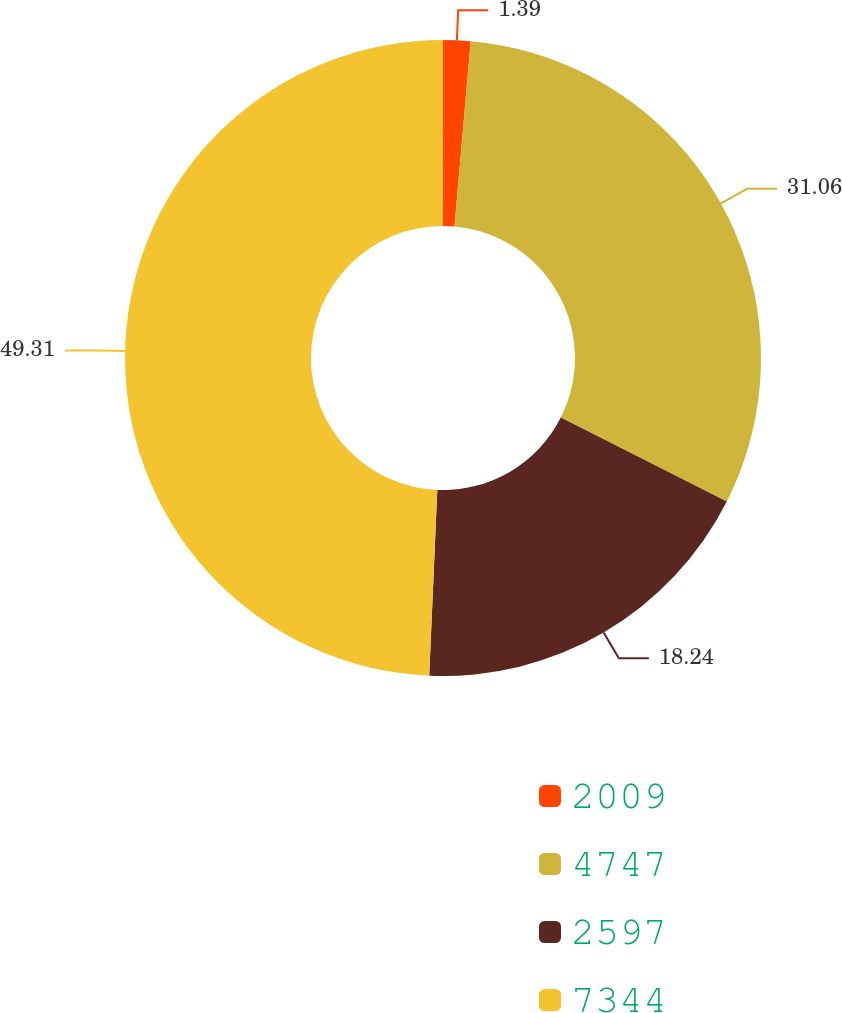Convert chart. <chart><loc_0><loc_0><loc_500><loc_500><pie_chart><fcel>2009<fcel>4747<fcel>2597<fcel>7344<nl><fcel>1.39%<fcel>31.06%<fcel>18.24%<fcel>49.31%<nl></chart> 